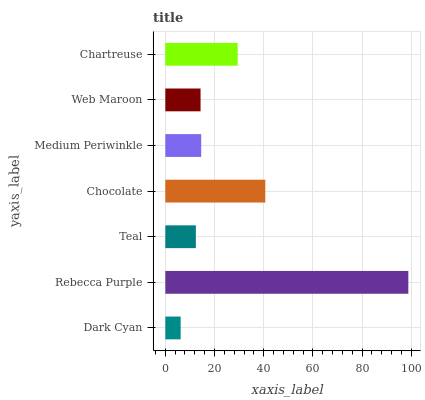Is Dark Cyan the minimum?
Answer yes or no. Yes. Is Rebecca Purple the maximum?
Answer yes or no. Yes. Is Teal the minimum?
Answer yes or no. No. Is Teal the maximum?
Answer yes or no. No. Is Rebecca Purple greater than Teal?
Answer yes or no. Yes. Is Teal less than Rebecca Purple?
Answer yes or no. Yes. Is Teal greater than Rebecca Purple?
Answer yes or no. No. Is Rebecca Purple less than Teal?
Answer yes or no. No. Is Medium Periwinkle the high median?
Answer yes or no. Yes. Is Medium Periwinkle the low median?
Answer yes or no. Yes. Is Dark Cyan the high median?
Answer yes or no. No. Is Dark Cyan the low median?
Answer yes or no. No. 